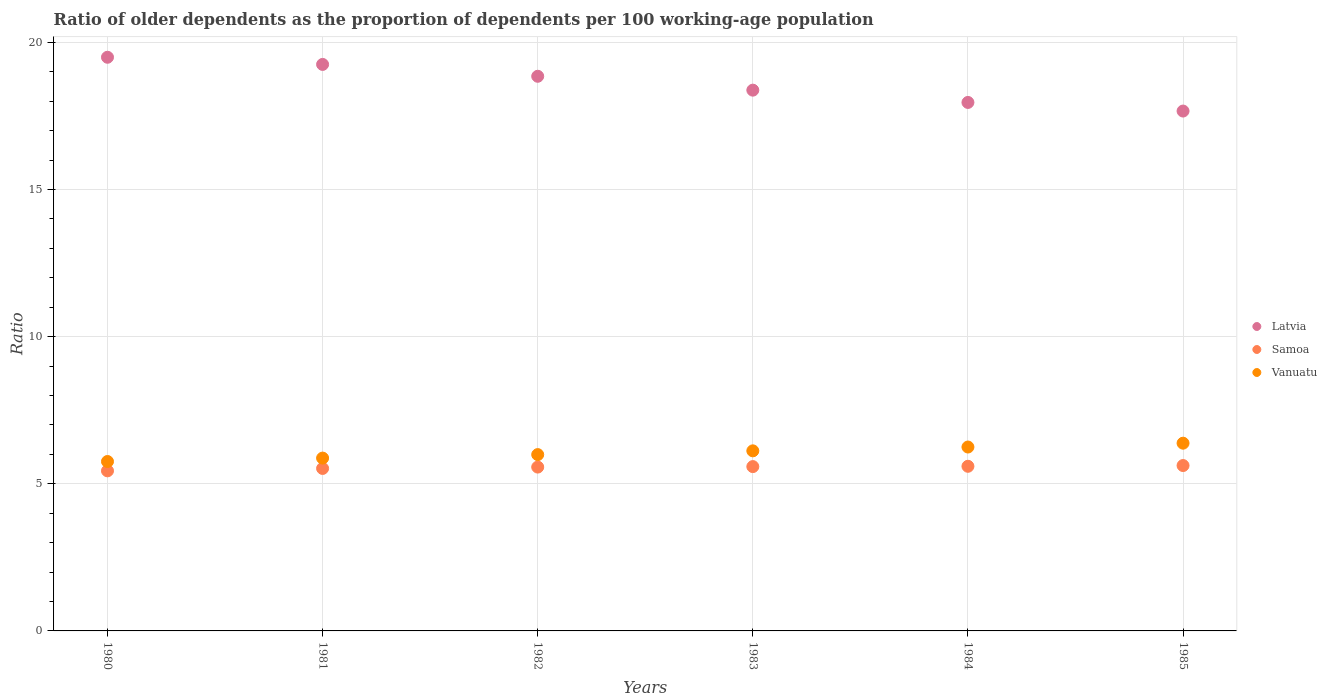Is the number of dotlines equal to the number of legend labels?
Offer a very short reply. Yes. What is the age dependency ratio(old) in Vanuatu in 1983?
Your answer should be very brief. 6.12. Across all years, what is the maximum age dependency ratio(old) in Samoa?
Offer a terse response. 5.62. Across all years, what is the minimum age dependency ratio(old) in Samoa?
Give a very brief answer. 5.44. In which year was the age dependency ratio(old) in Vanuatu maximum?
Your response must be concise. 1985. In which year was the age dependency ratio(old) in Latvia minimum?
Give a very brief answer. 1985. What is the total age dependency ratio(old) in Latvia in the graph?
Your response must be concise. 111.58. What is the difference between the age dependency ratio(old) in Vanuatu in 1982 and that in 1984?
Make the answer very short. -0.26. What is the difference between the age dependency ratio(old) in Samoa in 1983 and the age dependency ratio(old) in Latvia in 1982?
Make the answer very short. -13.26. What is the average age dependency ratio(old) in Samoa per year?
Keep it short and to the point. 5.55. In the year 1980, what is the difference between the age dependency ratio(old) in Vanuatu and age dependency ratio(old) in Samoa?
Make the answer very short. 0.32. In how many years, is the age dependency ratio(old) in Latvia greater than 12?
Offer a very short reply. 6. What is the ratio of the age dependency ratio(old) in Latvia in 1980 to that in 1981?
Offer a terse response. 1.01. Is the age dependency ratio(old) in Samoa in 1984 less than that in 1985?
Your answer should be compact. Yes. What is the difference between the highest and the second highest age dependency ratio(old) in Latvia?
Your answer should be compact. 0.24. What is the difference between the highest and the lowest age dependency ratio(old) in Samoa?
Offer a terse response. 0.18. Is it the case that in every year, the sum of the age dependency ratio(old) in Latvia and age dependency ratio(old) in Samoa  is greater than the age dependency ratio(old) in Vanuatu?
Keep it short and to the point. Yes. Does the age dependency ratio(old) in Vanuatu monotonically increase over the years?
Your answer should be compact. Yes. Is the age dependency ratio(old) in Latvia strictly less than the age dependency ratio(old) in Samoa over the years?
Your answer should be compact. No. How many dotlines are there?
Your response must be concise. 3. How many years are there in the graph?
Provide a succinct answer. 6. Are the values on the major ticks of Y-axis written in scientific E-notation?
Your answer should be compact. No. Does the graph contain any zero values?
Keep it short and to the point. No. Does the graph contain grids?
Your answer should be very brief. Yes. Where does the legend appear in the graph?
Your answer should be compact. Center right. How many legend labels are there?
Make the answer very short. 3. How are the legend labels stacked?
Give a very brief answer. Vertical. What is the title of the graph?
Make the answer very short. Ratio of older dependents as the proportion of dependents per 100 working-age population. Does "Liechtenstein" appear as one of the legend labels in the graph?
Offer a terse response. No. What is the label or title of the X-axis?
Your response must be concise. Years. What is the label or title of the Y-axis?
Your answer should be very brief. Ratio. What is the Ratio in Latvia in 1980?
Your answer should be compact. 19.49. What is the Ratio of Samoa in 1980?
Provide a succinct answer. 5.44. What is the Ratio of Vanuatu in 1980?
Your response must be concise. 5.76. What is the Ratio of Latvia in 1981?
Provide a succinct answer. 19.25. What is the Ratio in Samoa in 1981?
Your answer should be compact. 5.52. What is the Ratio in Vanuatu in 1981?
Provide a short and direct response. 5.87. What is the Ratio of Latvia in 1982?
Give a very brief answer. 18.85. What is the Ratio of Samoa in 1982?
Your answer should be compact. 5.57. What is the Ratio of Vanuatu in 1982?
Ensure brevity in your answer.  5.99. What is the Ratio in Latvia in 1983?
Make the answer very short. 18.37. What is the Ratio of Samoa in 1983?
Provide a short and direct response. 5.58. What is the Ratio of Vanuatu in 1983?
Your response must be concise. 6.12. What is the Ratio of Latvia in 1984?
Provide a succinct answer. 17.96. What is the Ratio of Samoa in 1984?
Keep it short and to the point. 5.59. What is the Ratio in Vanuatu in 1984?
Offer a very short reply. 6.25. What is the Ratio of Latvia in 1985?
Ensure brevity in your answer.  17.66. What is the Ratio in Samoa in 1985?
Give a very brief answer. 5.62. What is the Ratio in Vanuatu in 1985?
Provide a short and direct response. 6.38. Across all years, what is the maximum Ratio in Latvia?
Give a very brief answer. 19.49. Across all years, what is the maximum Ratio in Samoa?
Offer a terse response. 5.62. Across all years, what is the maximum Ratio of Vanuatu?
Give a very brief answer. 6.38. Across all years, what is the minimum Ratio of Latvia?
Your answer should be compact. 17.66. Across all years, what is the minimum Ratio of Samoa?
Your answer should be very brief. 5.44. Across all years, what is the minimum Ratio in Vanuatu?
Provide a succinct answer. 5.76. What is the total Ratio in Latvia in the graph?
Make the answer very short. 111.58. What is the total Ratio in Samoa in the graph?
Make the answer very short. 33.32. What is the total Ratio in Vanuatu in the graph?
Offer a very short reply. 36.37. What is the difference between the Ratio in Latvia in 1980 and that in 1981?
Your answer should be very brief. 0.24. What is the difference between the Ratio of Samoa in 1980 and that in 1981?
Provide a succinct answer. -0.08. What is the difference between the Ratio of Vanuatu in 1980 and that in 1981?
Your response must be concise. -0.12. What is the difference between the Ratio in Latvia in 1980 and that in 1982?
Your answer should be compact. 0.65. What is the difference between the Ratio of Samoa in 1980 and that in 1982?
Provide a succinct answer. -0.13. What is the difference between the Ratio in Vanuatu in 1980 and that in 1982?
Ensure brevity in your answer.  -0.23. What is the difference between the Ratio in Latvia in 1980 and that in 1983?
Keep it short and to the point. 1.12. What is the difference between the Ratio in Samoa in 1980 and that in 1983?
Give a very brief answer. -0.14. What is the difference between the Ratio in Vanuatu in 1980 and that in 1983?
Make the answer very short. -0.36. What is the difference between the Ratio of Latvia in 1980 and that in 1984?
Ensure brevity in your answer.  1.54. What is the difference between the Ratio in Samoa in 1980 and that in 1984?
Your answer should be compact. -0.15. What is the difference between the Ratio in Vanuatu in 1980 and that in 1984?
Your response must be concise. -0.49. What is the difference between the Ratio in Latvia in 1980 and that in 1985?
Keep it short and to the point. 1.83. What is the difference between the Ratio of Samoa in 1980 and that in 1985?
Your answer should be compact. -0.18. What is the difference between the Ratio of Vanuatu in 1980 and that in 1985?
Offer a terse response. -0.62. What is the difference between the Ratio in Latvia in 1981 and that in 1982?
Offer a terse response. 0.4. What is the difference between the Ratio of Samoa in 1981 and that in 1982?
Offer a very short reply. -0.05. What is the difference between the Ratio of Vanuatu in 1981 and that in 1982?
Keep it short and to the point. -0.12. What is the difference between the Ratio of Latvia in 1981 and that in 1983?
Your response must be concise. 0.87. What is the difference between the Ratio in Samoa in 1981 and that in 1983?
Your answer should be very brief. -0.06. What is the difference between the Ratio of Vanuatu in 1981 and that in 1983?
Your response must be concise. -0.25. What is the difference between the Ratio of Latvia in 1981 and that in 1984?
Give a very brief answer. 1.29. What is the difference between the Ratio of Samoa in 1981 and that in 1984?
Offer a very short reply. -0.07. What is the difference between the Ratio of Vanuatu in 1981 and that in 1984?
Keep it short and to the point. -0.38. What is the difference between the Ratio in Latvia in 1981 and that in 1985?
Provide a succinct answer. 1.58. What is the difference between the Ratio of Samoa in 1981 and that in 1985?
Ensure brevity in your answer.  -0.1. What is the difference between the Ratio of Vanuatu in 1981 and that in 1985?
Your response must be concise. -0.51. What is the difference between the Ratio in Latvia in 1982 and that in 1983?
Offer a terse response. 0.47. What is the difference between the Ratio in Samoa in 1982 and that in 1983?
Your response must be concise. -0.02. What is the difference between the Ratio of Vanuatu in 1982 and that in 1983?
Give a very brief answer. -0.13. What is the difference between the Ratio in Latvia in 1982 and that in 1984?
Your response must be concise. 0.89. What is the difference between the Ratio in Samoa in 1982 and that in 1984?
Keep it short and to the point. -0.03. What is the difference between the Ratio of Vanuatu in 1982 and that in 1984?
Keep it short and to the point. -0.26. What is the difference between the Ratio of Latvia in 1982 and that in 1985?
Keep it short and to the point. 1.18. What is the difference between the Ratio of Samoa in 1982 and that in 1985?
Offer a terse response. -0.05. What is the difference between the Ratio of Vanuatu in 1982 and that in 1985?
Keep it short and to the point. -0.39. What is the difference between the Ratio in Latvia in 1983 and that in 1984?
Offer a very short reply. 0.42. What is the difference between the Ratio in Samoa in 1983 and that in 1984?
Provide a short and direct response. -0.01. What is the difference between the Ratio in Vanuatu in 1983 and that in 1984?
Ensure brevity in your answer.  -0.13. What is the difference between the Ratio of Latvia in 1983 and that in 1985?
Make the answer very short. 0.71. What is the difference between the Ratio of Samoa in 1983 and that in 1985?
Give a very brief answer. -0.04. What is the difference between the Ratio in Vanuatu in 1983 and that in 1985?
Your response must be concise. -0.26. What is the difference between the Ratio of Latvia in 1984 and that in 1985?
Ensure brevity in your answer.  0.29. What is the difference between the Ratio in Samoa in 1984 and that in 1985?
Provide a succinct answer. -0.03. What is the difference between the Ratio of Vanuatu in 1984 and that in 1985?
Your answer should be very brief. -0.13. What is the difference between the Ratio in Latvia in 1980 and the Ratio in Samoa in 1981?
Provide a short and direct response. 13.97. What is the difference between the Ratio of Latvia in 1980 and the Ratio of Vanuatu in 1981?
Provide a short and direct response. 13.62. What is the difference between the Ratio in Samoa in 1980 and the Ratio in Vanuatu in 1981?
Give a very brief answer. -0.43. What is the difference between the Ratio in Latvia in 1980 and the Ratio in Samoa in 1982?
Offer a very short reply. 13.93. What is the difference between the Ratio of Latvia in 1980 and the Ratio of Vanuatu in 1982?
Provide a short and direct response. 13.5. What is the difference between the Ratio of Samoa in 1980 and the Ratio of Vanuatu in 1982?
Keep it short and to the point. -0.55. What is the difference between the Ratio in Latvia in 1980 and the Ratio in Samoa in 1983?
Offer a terse response. 13.91. What is the difference between the Ratio of Latvia in 1980 and the Ratio of Vanuatu in 1983?
Provide a succinct answer. 13.37. What is the difference between the Ratio of Samoa in 1980 and the Ratio of Vanuatu in 1983?
Ensure brevity in your answer.  -0.68. What is the difference between the Ratio of Latvia in 1980 and the Ratio of Samoa in 1984?
Provide a succinct answer. 13.9. What is the difference between the Ratio of Latvia in 1980 and the Ratio of Vanuatu in 1984?
Your response must be concise. 13.24. What is the difference between the Ratio in Samoa in 1980 and the Ratio in Vanuatu in 1984?
Your answer should be very brief. -0.81. What is the difference between the Ratio in Latvia in 1980 and the Ratio in Samoa in 1985?
Keep it short and to the point. 13.87. What is the difference between the Ratio in Latvia in 1980 and the Ratio in Vanuatu in 1985?
Offer a very short reply. 13.11. What is the difference between the Ratio of Samoa in 1980 and the Ratio of Vanuatu in 1985?
Your answer should be compact. -0.94. What is the difference between the Ratio in Latvia in 1981 and the Ratio in Samoa in 1982?
Your answer should be compact. 13.68. What is the difference between the Ratio of Latvia in 1981 and the Ratio of Vanuatu in 1982?
Provide a succinct answer. 13.26. What is the difference between the Ratio in Samoa in 1981 and the Ratio in Vanuatu in 1982?
Your answer should be very brief. -0.47. What is the difference between the Ratio of Latvia in 1981 and the Ratio of Samoa in 1983?
Keep it short and to the point. 13.67. What is the difference between the Ratio in Latvia in 1981 and the Ratio in Vanuatu in 1983?
Ensure brevity in your answer.  13.13. What is the difference between the Ratio of Samoa in 1981 and the Ratio of Vanuatu in 1983?
Ensure brevity in your answer.  -0.6. What is the difference between the Ratio in Latvia in 1981 and the Ratio in Samoa in 1984?
Offer a very short reply. 13.65. What is the difference between the Ratio in Latvia in 1981 and the Ratio in Vanuatu in 1984?
Keep it short and to the point. 13. What is the difference between the Ratio in Samoa in 1981 and the Ratio in Vanuatu in 1984?
Ensure brevity in your answer.  -0.73. What is the difference between the Ratio of Latvia in 1981 and the Ratio of Samoa in 1985?
Provide a short and direct response. 13.63. What is the difference between the Ratio in Latvia in 1981 and the Ratio in Vanuatu in 1985?
Offer a terse response. 12.87. What is the difference between the Ratio in Samoa in 1981 and the Ratio in Vanuatu in 1985?
Keep it short and to the point. -0.86. What is the difference between the Ratio in Latvia in 1982 and the Ratio in Samoa in 1983?
Give a very brief answer. 13.26. What is the difference between the Ratio of Latvia in 1982 and the Ratio of Vanuatu in 1983?
Offer a very short reply. 12.73. What is the difference between the Ratio in Samoa in 1982 and the Ratio in Vanuatu in 1983?
Provide a short and direct response. -0.55. What is the difference between the Ratio in Latvia in 1982 and the Ratio in Samoa in 1984?
Ensure brevity in your answer.  13.25. What is the difference between the Ratio in Latvia in 1982 and the Ratio in Vanuatu in 1984?
Your answer should be very brief. 12.6. What is the difference between the Ratio of Samoa in 1982 and the Ratio of Vanuatu in 1984?
Ensure brevity in your answer.  -0.68. What is the difference between the Ratio in Latvia in 1982 and the Ratio in Samoa in 1985?
Ensure brevity in your answer.  13.23. What is the difference between the Ratio in Latvia in 1982 and the Ratio in Vanuatu in 1985?
Ensure brevity in your answer.  12.47. What is the difference between the Ratio of Samoa in 1982 and the Ratio of Vanuatu in 1985?
Your answer should be very brief. -0.81. What is the difference between the Ratio of Latvia in 1983 and the Ratio of Samoa in 1984?
Your answer should be compact. 12.78. What is the difference between the Ratio in Latvia in 1983 and the Ratio in Vanuatu in 1984?
Make the answer very short. 12.13. What is the difference between the Ratio in Samoa in 1983 and the Ratio in Vanuatu in 1984?
Offer a terse response. -0.67. What is the difference between the Ratio of Latvia in 1983 and the Ratio of Samoa in 1985?
Provide a short and direct response. 12.76. What is the difference between the Ratio in Latvia in 1983 and the Ratio in Vanuatu in 1985?
Make the answer very short. 12. What is the difference between the Ratio in Samoa in 1983 and the Ratio in Vanuatu in 1985?
Give a very brief answer. -0.8. What is the difference between the Ratio of Latvia in 1984 and the Ratio of Samoa in 1985?
Your answer should be very brief. 12.34. What is the difference between the Ratio in Latvia in 1984 and the Ratio in Vanuatu in 1985?
Give a very brief answer. 11.58. What is the difference between the Ratio of Samoa in 1984 and the Ratio of Vanuatu in 1985?
Provide a short and direct response. -0.78. What is the average Ratio of Latvia per year?
Provide a succinct answer. 18.6. What is the average Ratio in Samoa per year?
Provide a short and direct response. 5.55. What is the average Ratio of Vanuatu per year?
Ensure brevity in your answer.  6.06. In the year 1980, what is the difference between the Ratio in Latvia and Ratio in Samoa?
Your answer should be very brief. 14.05. In the year 1980, what is the difference between the Ratio of Latvia and Ratio of Vanuatu?
Provide a succinct answer. 13.74. In the year 1980, what is the difference between the Ratio of Samoa and Ratio of Vanuatu?
Provide a succinct answer. -0.32. In the year 1981, what is the difference between the Ratio of Latvia and Ratio of Samoa?
Offer a very short reply. 13.73. In the year 1981, what is the difference between the Ratio in Latvia and Ratio in Vanuatu?
Keep it short and to the point. 13.38. In the year 1981, what is the difference between the Ratio of Samoa and Ratio of Vanuatu?
Ensure brevity in your answer.  -0.35. In the year 1982, what is the difference between the Ratio of Latvia and Ratio of Samoa?
Give a very brief answer. 13.28. In the year 1982, what is the difference between the Ratio of Latvia and Ratio of Vanuatu?
Your response must be concise. 12.85. In the year 1982, what is the difference between the Ratio in Samoa and Ratio in Vanuatu?
Provide a short and direct response. -0.42. In the year 1983, what is the difference between the Ratio of Latvia and Ratio of Samoa?
Offer a very short reply. 12.79. In the year 1983, what is the difference between the Ratio in Latvia and Ratio in Vanuatu?
Make the answer very short. 12.26. In the year 1983, what is the difference between the Ratio of Samoa and Ratio of Vanuatu?
Give a very brief answer. -0.54. In the year 1984, what is the difference between the Ratio of Latvia and Ratio of Samoa?
Offer a very short reply. 12.36. In the year 1984, what is the difference between the Ratio of Latvia and Ratio of Vanuatu?
Provide a succinct answer. 11.71. In the year 1984, what is the difference between the Ratio in Samoa and Ratio in Vanuatu?
Offer a terse response. -0.65. In the year 1985, what is the difference between the Ratio of Latvia and Ratio of Samoa?
Provide a succinct answer. 12.04. In the year 1985, what is the difference between the Ratio of Latvia and Ratio of Vanuatu?
Offer a very short reply. 11.29. In the year 1985, what is the difference between the Ratio of Samoa and Ratio of Vanuatu?
Give a very brief answer. -0.76. What is the ratio of the Ratio of Latvia in 1980 to that in 1981?
Your answer should be compact. 1.01. What is the ratio of the Ratio in Samoa in 1980 to that in 1981?
Your response must be concise. 0.99. What is the ratio of the Ratio of Vanuatu in 1980 to that in 1981?
Your response must be concise. 0.98. What is the ratio of the Ratio of Latvia in 1980 to that in 1982?
Provide a succinct answer. 1.03. What is the ratio of the Ratio of Vanuatu in 1980 to that in 1982?
Ensure brevity in your answer.  0.96. What is the ratio of the Ratio in Latvia in 1980 to that in 1983?
Your response must be concise. 1.06. What is the ratio of the Ratio in Samoa in 1980 to that in 1983?
Your response must be concise. 0.97. What is the ratio of the Ratio in Vanuatu in 1980 to that in 1983?
Offer a very short reply. 0.94. What is the ratio of the Ratio of Latvia in 1980 to that in 1984?
Offer a very short reply. 1.09. What is the ratio of the Ratio in Samoa in 1980 to that in 1984?
Provide a succinct answer. 0.97. What is the ratio of the Ratio in Vanuatu in 1980 to that in 1984?
Make the answer very short. 0.92. What is the ratio of the Ratio of Latvia in 1980 to that in 1985?
Keep it short and to the point. 1.1. What is the ratio of the Ratio of Vanuatu in 1980 to that in 1985?
Ensure brevity in your answer.  0.9. What is the ratio of the Ratio in Latvia in 1981 to that in 1982?
Give a very brief answer. 1.02. What is the ratio of the Ratio of Vanuatu in 1981 to that in 1982?
Your answer should be compact. 0.98. What is the ratio of the Ratio of Latvia in 1981 to that in 1983?
Your response must be concise. 1.05. What is the ratio of the Ratio of Samoa in 1981 to that in 1983?
Make the answer very short. 0.99. What is the ratio of the Ratio in Vanuatu in 1981 to that in 1983?
Give a very brief answer. 0.96. What is the ratio of the Ratio in Latvia in 1981 to that in 1984?
Your answer should be very brief. 1.07. What is the ratio of the Ratio of Samoa in 1981 to that in 1984?
Ensure brevity in your answer.  0.99. What is the ratio of the Ratio of Vanuatu in 1981 to that in 1984?
Offer a very short reply. 0.94. What is the ratio of the Ratio of Latvia in 1981 to that in 1985?
Keep it short and to the point. 1.09. What is the ratio of the Ratio of Samoa in 1981 to that in 1985?
Ensure brevity in your answer.  0.98. What is the ratio of the Ratio of Vanuatu in 1981 to that in 1985?
Your answer should be very brief. 0.92. What is the ratio of the Ratio in Latvia in 1982 to that in 1983?
Your response must be concise. 1.03. What is the ratio of the Ratio in Vanuatu in 1982 to that in 1983?
Provide a short and direct response. 0.98. What is the ratio of the Ratio of Latvia in 1982 to that in 1984?
Your answer should be compact. 1.05. What is the ratio of the Ratio in Samoa in 1982 to that in 1984?
Your response must be concise. 1. What is the ratio of the Ratio of Vanuatu in 1982 to that in 1984?
Offer a very short reply. 0.96. What is the ratio of the Ratio of Latvia in 1982 to that in 1985?
Give a very brief answer. 1.07. What is the ratio of the Ratio of Vanuatu in 1982 to that in 1985?
Offer a terse response. 0.94. What is the ratio of the Ratio in Latvia in 1983 to that in 1984?
Provide a short and direct response. 1.02. What is the ratio of the Ratio of Vanuatu in 1983 to that in 1984?
Provide a succinct answer. 0.98. What is the ratio of the Ratio of Latvia in 1983 to that in 1985?
Ensure brevity in your answer.  1.04. What is the ratio of the Ratio of Vanuatu in 1983 to that in 1985?
Offer a terse response. 0.96. What is the ratio of the Ratio in Latvia in 1984 to that in 1985?
Your response must be concise. 1.02. What is the ratio of the Ratio in Vanuatu in 1984 to that in 1985?
Your response must be concise. 0.98. What is the difference between the highest and the second highest Ratio of Latvia?
Offer a very short reply. 0.24. What is the difference between the highest and the second highest Ratio in Samoa?
Make the answer very short. 0.03. What is the difference between the highest and the second highest Ratio in Vanuatu?
Offer a very short reply. 0.13. What is the difference between the highest and the lowest Ratio in Latvia?
Provide a short and direct response. 1.83. What is the difference between the highest and the lowest Ratio in Samoa?
Give a very brief answer. 0.18. What is the difference between the highest and the lowest Ratio in Vanuatu?
Offer a terse response. 0.62. 